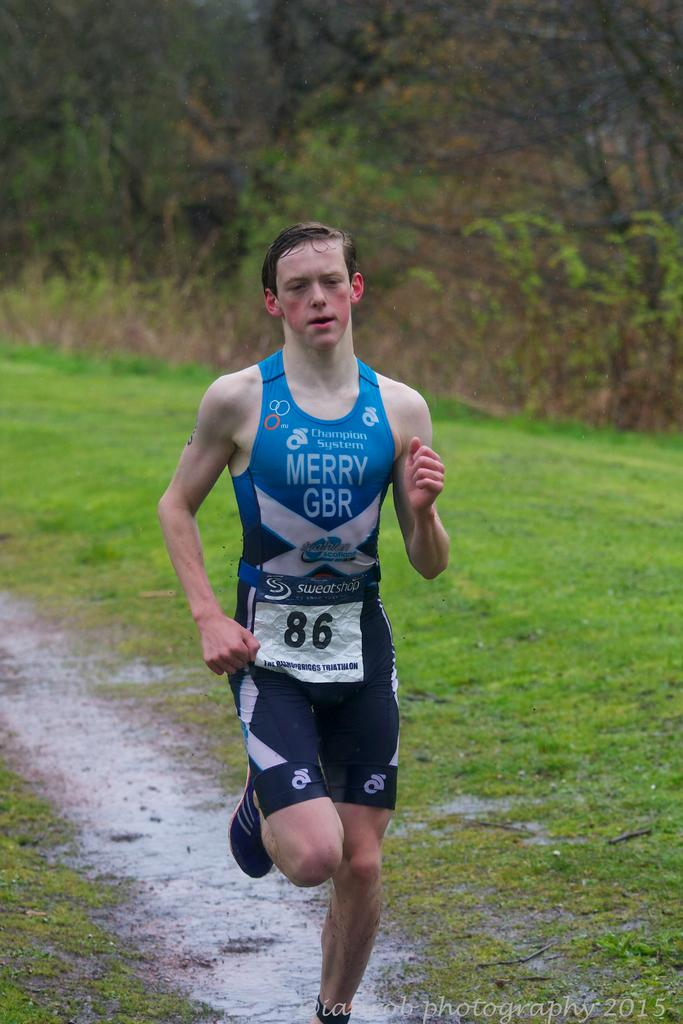<image>
Create a compact narrative representing the image presented. Number 86 is running on a cross country track. 